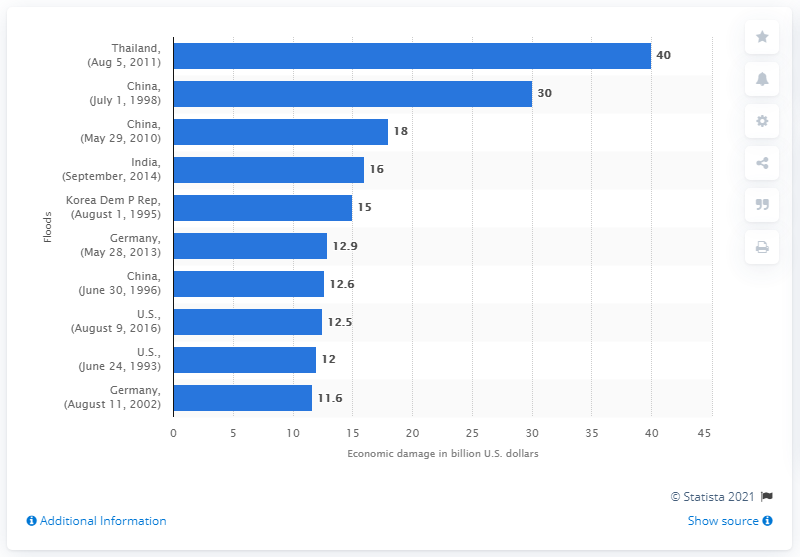Identify some key points in this picture. An estimated value of 30 billion yuan was the damage caused by a flood in China in 1998. 